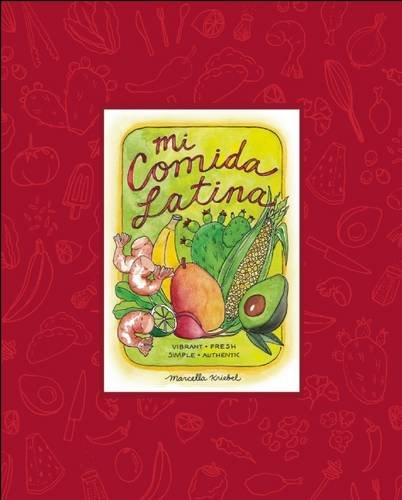How is the book organized? The book is organized by country, each section introducing traditional dishes from nations across Latin America, accompanied by personal stories and stunning illustrations that bring the flavors and cultures to life. 